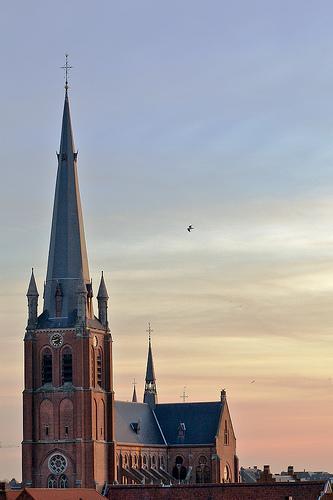How many churches are there?
Give a very brief answer. 1. How many little spires are on the lower half of the building?
Give a very brief answer. 1. 